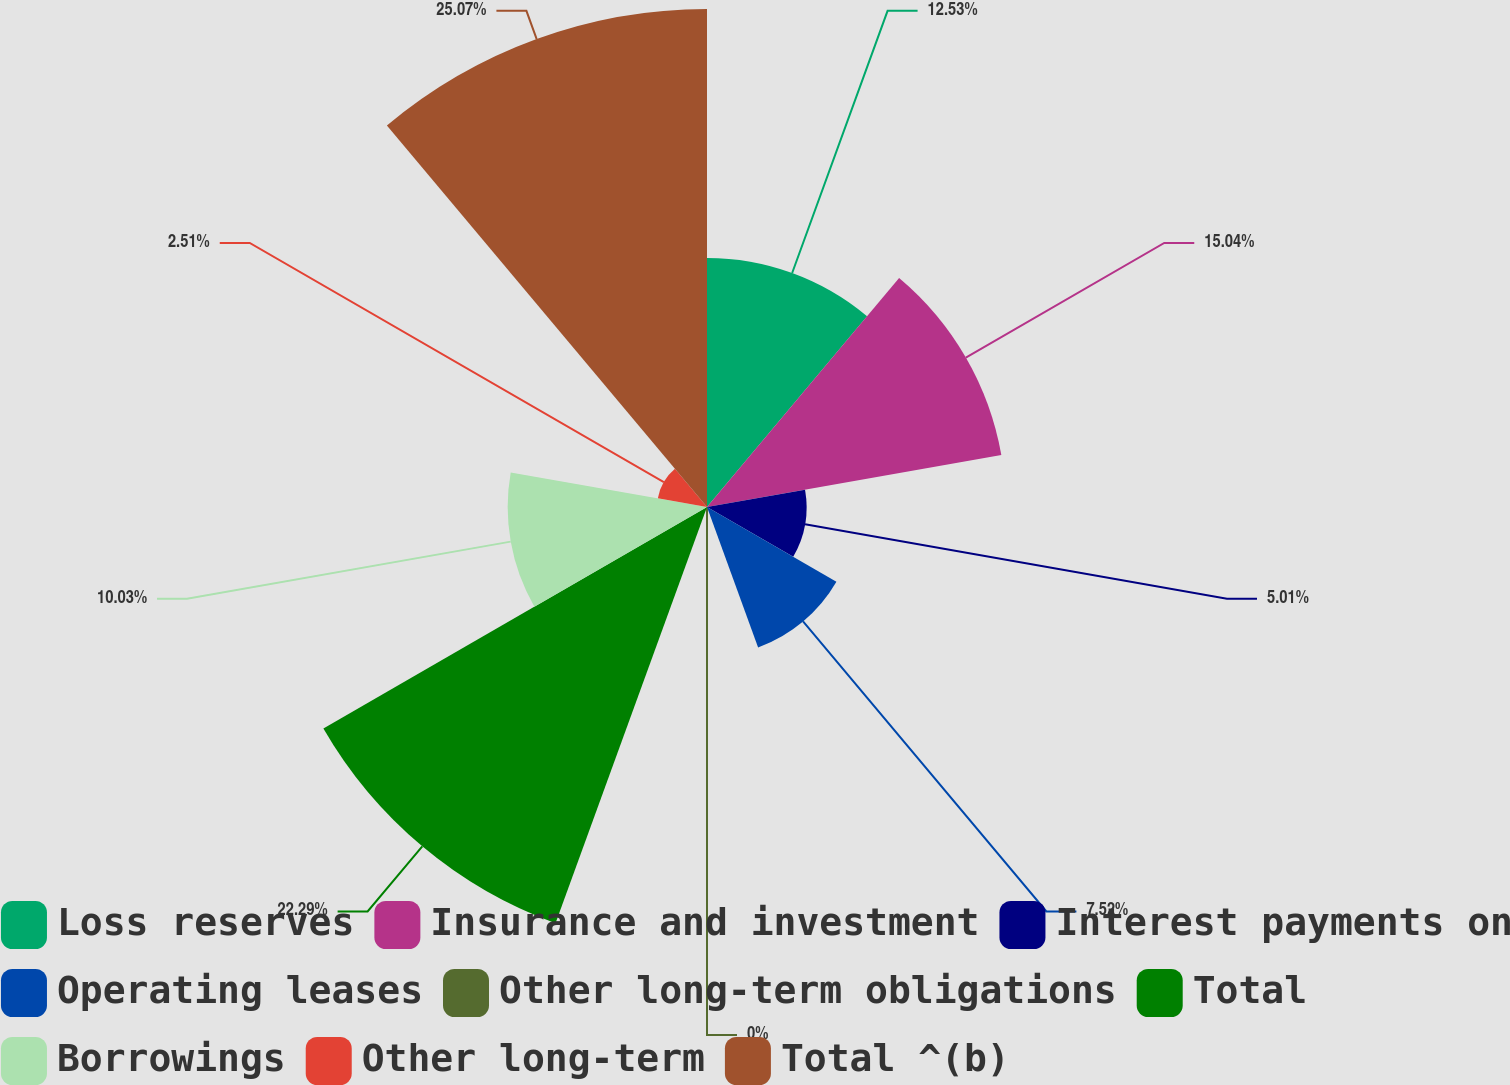<chart> <loc_0><loc_0><loc_500><loc_500><pie_chart><fcel>Loss reserves<fcel>Insurance and investment<fcel>Interest payments on<fcel>Operating leases<fcel>Other long-term obligations<fcel>Total<fcel>Borrowings<fcel>Other long-term<fcel>Total ^(b)<nl><fcel>12.53%<fcel>15.04%<fcel>5.01%<fcel>7.52%<fcel>0.0%<fcel>22.29%<fcel>10.03%<fcel>2.51%<fcel>25.06%<nl></chart> 